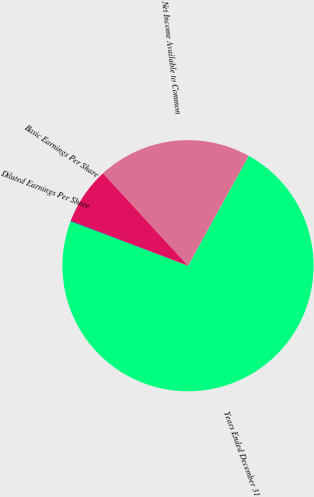Convert chart to OTSL. <chart><loc_0><loc_0><loc_500><loc_500><pie_chart><fcel>Years Ended December 31<fcel>Net Income Available to Common<fcel>Basic Earnings Per Share<fcel>Diluted Earnings Per Share<nl><fcel>72.72%<fcel>19.87%<fcel>7.34%<fcel>0.07%<nl></chart> 